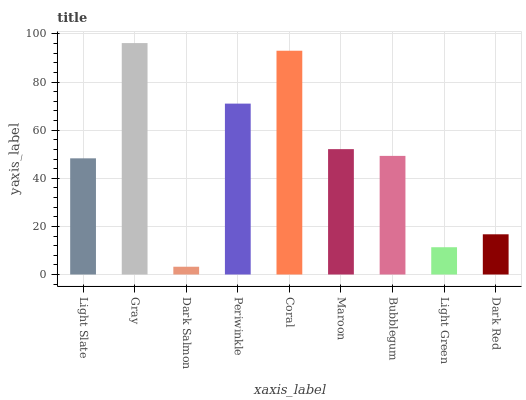Is Dark Salmon the minimum?
Answer yes or no. Yes. Is Gray the maximum?
Answer yes or no. Yes. Is Gray the minimum?
Answer yes or no. No. Is Dark Salmon the maximum?
Answer yes or no. No. Is Gray greater than Dark Salmon?
Answer yes or no. Yes. Is Dark Salmon less than Gray?
Answer yes or no. Yes. Is Dark Salmon greater than Gray?
Answer yes or no. No. Is Gray less than Dark Salmon?
Answer yes or no. No. Is Bubblegum the high median?
Answer yes or no. Yes. Is Bubblegum the low median?
Answer yes or no. Yes. Is Light Slate the high median?
Answer yes or no. No. Is Periwinkle the low median?
Answer yes or no. No. 